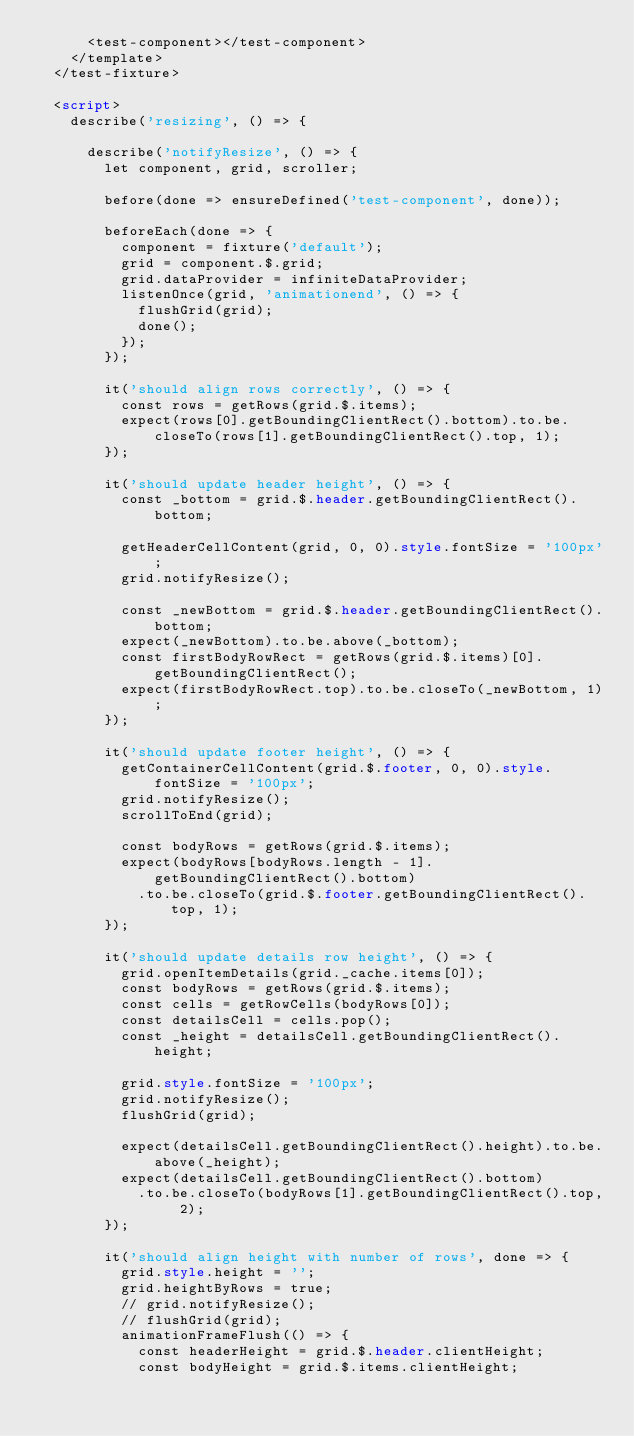<code> <loc_0><loc_0><loc_500><loc_500><_HTML_>      <test-component></test-component>
    </template>
  </test-fixture>

  <script>
    describe('resizing', () => {

      describe('notifyResize', () => {
        let component, grid, scroller;

        before(done => ensureDefined('test-component', done));

        beforeEach(done => {
          component = fixture('default');
          grid = component.$.grid;
          grid.dataProvider = infiniteDataProvider;
          listenOnce(grid, 'animationend', () => {
            flushGrid(grid);
            done();
          });
        });

        it('should align rows correctly', () => {
          const rows = getRows(grid.$.items);
          expect(rows[0].getBoundingClientRect().bottom).to.be.closeTo(rows[1].getBoundingClientRect().top, 1);
        });

        it('should update header height', () => {
          const _bottom = grid.$.header.getBoundingClientRect().bottom;

          getHeaderCellContent(grid, 0, 0).style.fontSize = '100px';
          grid.notifyResize();

          const _newBottom = grid.$.header.getBoundingClientRect().bottom;
          expect(_newBottom).to.be.above(_bottom);
          const firstBodyRowRect = getRows(grid.$.items)[0].getBoundingClientRect();
          expect(firstBodyRowRect.top).to.be.closeTo(_newBottom, 1);
        });

        it('should update footer height', () => {
          getContainerCellContent(grid.$.footer, 0, 0).style.fontSize = '100px';
          grid.notifyResize();
          scrollToEnd(grid);

          const bodyRows = getRows(grid.$.items);
          expect(bodyRows[bodyRows.length - 1].getBoundingClientRect().bottom)
            .to.be.closeTo(grid.$.footer.getBoundingClientRect().top, 1);
        });

        it('should update details row height', () => {
          grid.openItemDetails(grid._cache.items[0]);
          const bodyRows = getRows(grid.$.items);
          const cells = getRowCells(bodyRows[0]);
          const detailsCell = cells.pop();
          const _height = detailsCell.getBoundingClientRect().height;

          grid.style.fontSize = '100px';
          grid.notifyResize();
          flushGrid(grid);

          expect(detailsCell.getBoundingClientRect().height).to.be.above(_height);
          expect(detailsCell.getBoundingClientRect().bottom)
            .to.be.closeTo(bodyRows[1].getBoundingClientRect().top, 2);
        });

        it('should align height with number of rows', done => {
          grid.style.height = '';
          grid.heightByRows = true;
          // grid.notifyResize();
          // flushGrid(grid);
          animationFrameFlush(() => {
            const headerHeight = grid.$.header.clientHeight;
            const bodyHeight = grid.$.items.clientHeight;</code> 